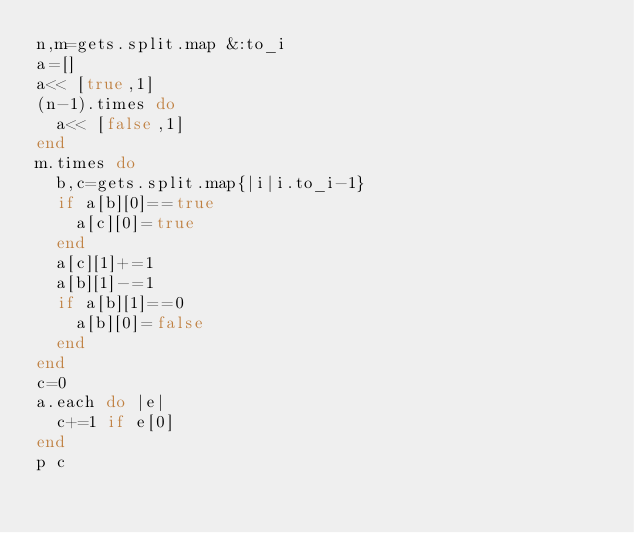<code> <loc_0><loc_0><loc_500><loc_500><_Ruby_>n,m=gets.split.map &:to_i
a=[]
a<< [true,1]
(n-1).times do
  a<< [false,1]
end
m.times do
  b,c=gets.split.map{|i|i.to_i-1}
  if a[b][0]==true
    a[c][0]=true
  end
  a[c][1]+=1
  a[b][1]-=1
  if a[b][1]==0
    a[b][0]=false
  end
end
c=0
a.each do |e|
  c+=1 if e[0]
end
p c</code> 